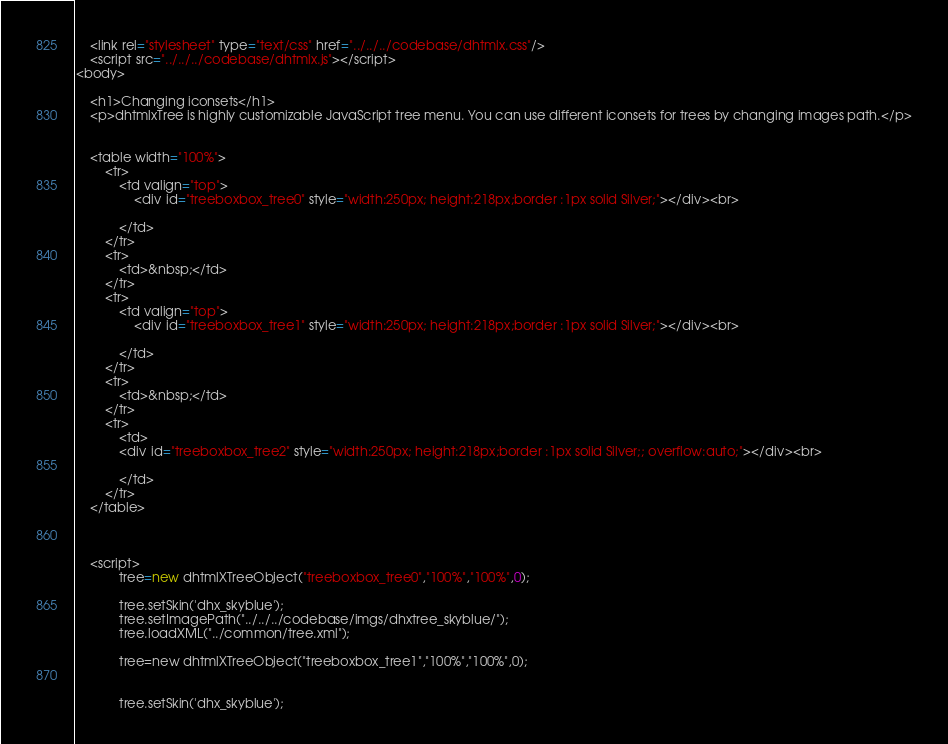Convert code to text. <code><loc_0><loc_0><loc_500><loc_500><_HTML_>	<link rel="stylesheet" type="text/css" href="../../../codebase/dhtmlx.css"/>
	<script src="../../../codebase/dhtmlx.js"></script>
<body>
	
	<h1>Changing iconsets</h1>
	<p>dhtmlxTree is highly customizable JavaScript tree menu. You can use different iconsets for trees by changing images path.</p>
		
	
	<table width="100%">
		<tr>
			<td valign="top">
				<div id="treeboxbox_tree0" style="width:250px; height:218px;border :1px solid Silver;"></div><br>

			</td>
		</tr>
		<tr>
			<td>&nbsp;</td>
		</tr>
		<tr>
			<td valign="top">
				<div id="treeboxbox_tree1" style="width:250px; height:218px;border :1px solid Silver;"></div><br>

			</td>
		</tr>
		<tr>
			<td>&nbsp;</td>
		</tr>
		<tr>
			<td>
			<div id="treeboxbox_tree2" style="width:250px; height:218px;border :1px solid Silver;; overflow:auto;"></div><br>
			
			</td>
		</tr>
	</table>
	

 
	<script>
			tree=new dhtmlXTreeObject("treeboxbox_tree0","100%","100%",0);

			tree.setSkin('dhx_skyblue');
			tree.setImagePath("../../../codebase/imgs/dhxtree_skyblue/");
			tree.loadXML("../common/tree.xml");
			
			tree=new dhtmlXTreeObject("treeboxbox_tree1","100%","100%",0);

			
			tree.setSkin('dhx_skyblue');</code> 